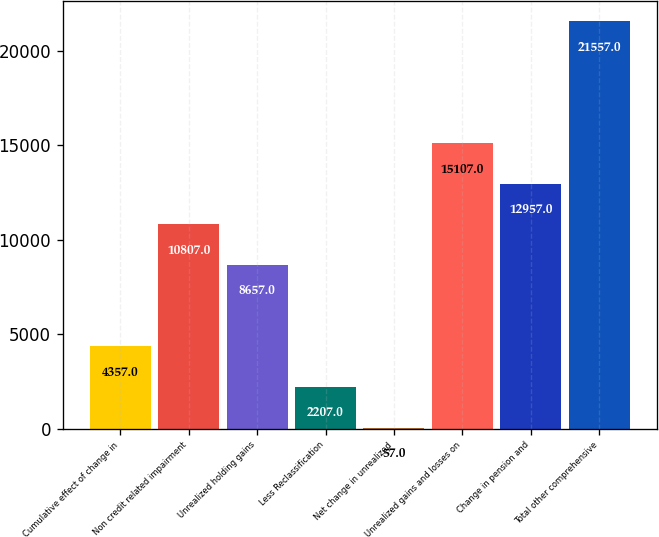Convert chart to OTSL. <chart><loc_0><loc_0><loc_500><loc_500><bar_chart><fcel>Cumulative effect of change in<fcel>Non credit related impairment<fcel>Unrealized holding gains<fcel>Less Reclassification<fcel>Net change in unrealized<fcel>Unrealized gains and losses on<fcel>Change in pension and<fcel>Total other comprehensive<nl><fcel>4357<fcel>10807<fcel>8657<fcel>2207<fcel>57<fcel>15107<fcel>12957<fcel>21557<nl></chart> 